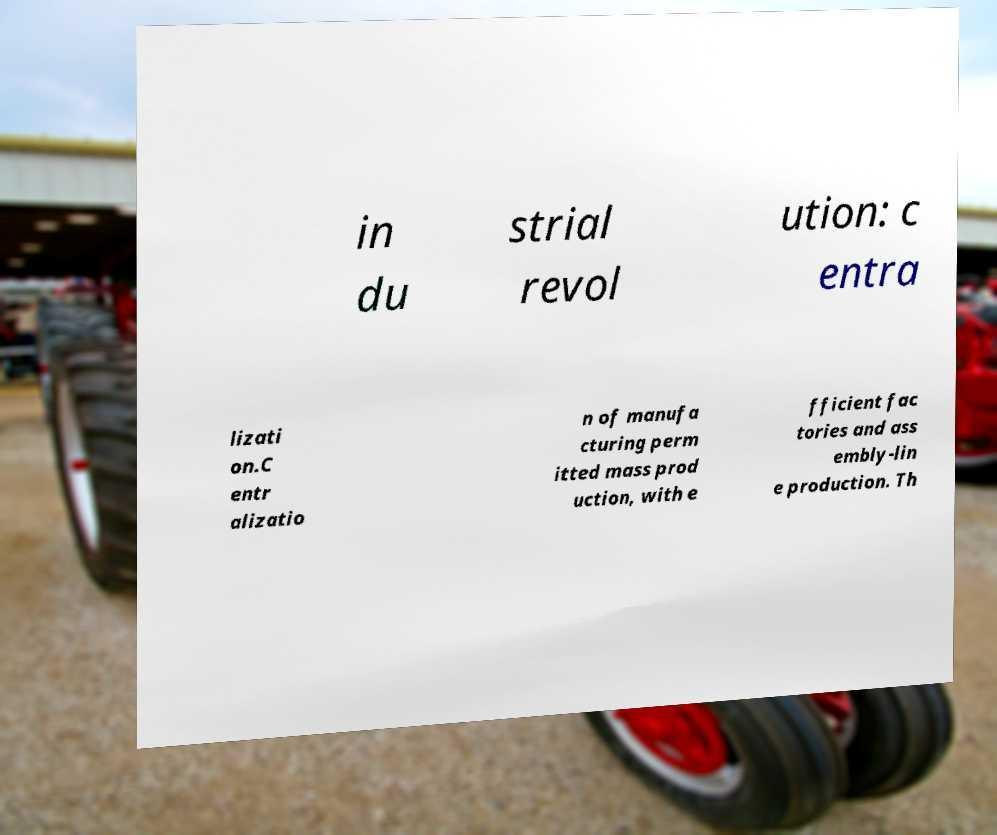Could you assist in decoding the text presented in this image and type it out clearly? in du strial revol ution: c entra lizati on.C entr alizatio n of manufa cturing perm itted mass prod uction, with e fficient fac tories and ass embly-lin e production. Th 